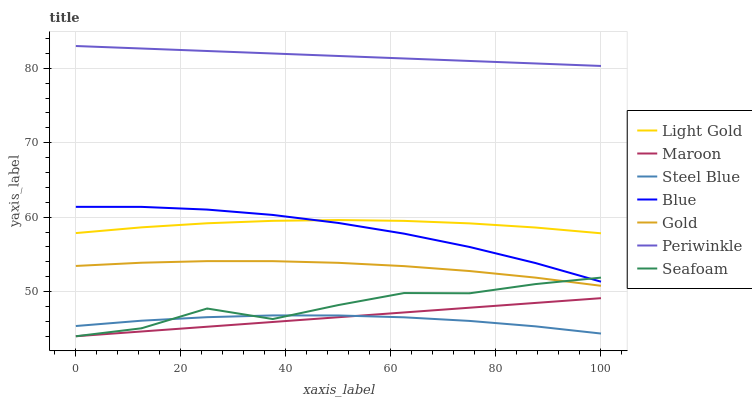Does Steel Blue have the minimum area under the curve?
Answer yes or no. Yes. Does Periwinkle have the maximum area under the curve?
Answer yes or no. Yes. Does Gold have the minimum area under the curve?
Answer yes or no. No. Does Gold have the maximum area under the curve?
Answer yes or no. No. Is Maroon the smoothest?
Answer yes or no. Yes. Is Seafoam the roughest?
Answer yes or no. Yes. Is Gold the smoothest?
Answer yes or no. No. Is Gold the roughest?
Answer yes or no. No. Does Maroon have the lowest value?
Answer yes or no. Yes. Does Gold have the lowest value?
Answer yes or no. No. Does Periwinkle have the highest value?
Answer yes or no. Yes. Does Gold have the highest value?
Answer yes or no. No. Is Steel Blue less than Gold?
Answer yes or no. Yes. Is Periwinkle greater than Gold?
Answer yes or no. Yes. Does Seafoam intersect Gold?
Answer yes or no. Yes. Is Seafoam less than Gold?
Answer yes or no. No. Is Seafoam greater than Gold?
Answer yes or no. No. Does Steel Blue intersect Gold?
Answer yes or no. No. 